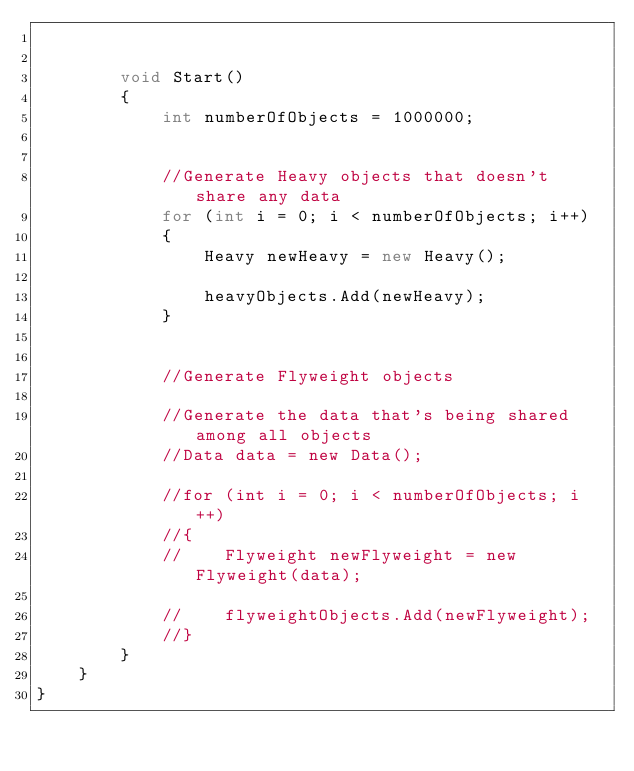<code> <loc_0><loc_0><loc_500><loc_500><_C#_>

        void Start()
        {
            int numberOfObjects = 1000000;


            //Generate Heavy objects that doesn't share any data
            for (int i = 0; i < numberOfObjects; i++)
            {
                Heavy newHeavy = new Heavy();

                heavyObjects.Add(newHeavy);
            }


            //Generate Flyweight objects

            //Generate the data that's being shared among all objects
            //Data data = new Data();

            //for (int i = 0; i < numberOfObjects; i++)
            //{
            //    Flyweight newFlyweight = new Flyweight(data);

            //    flyweightObjects.Add(newFlyweight);
            //}
        }
    }
}
</code> 